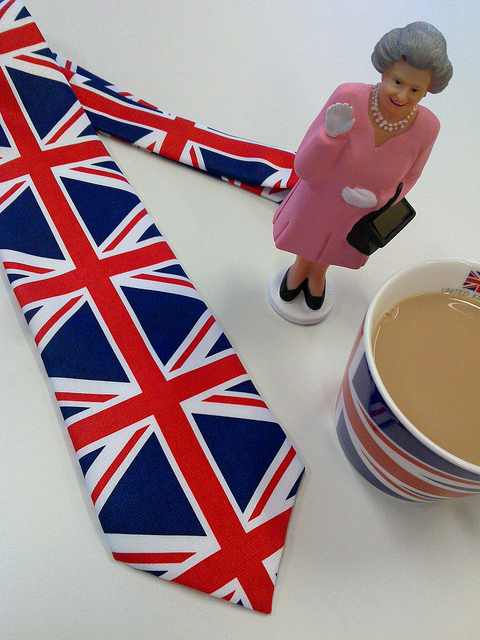<image>What is this shoe made of? It is unknown what the shoe is made of. The material could be either leather, fabric, plastic, wax or glass. What is this shoe made of? I don't know what this shoe is made of. It can be made of leather, fabric, plastic or glass. 